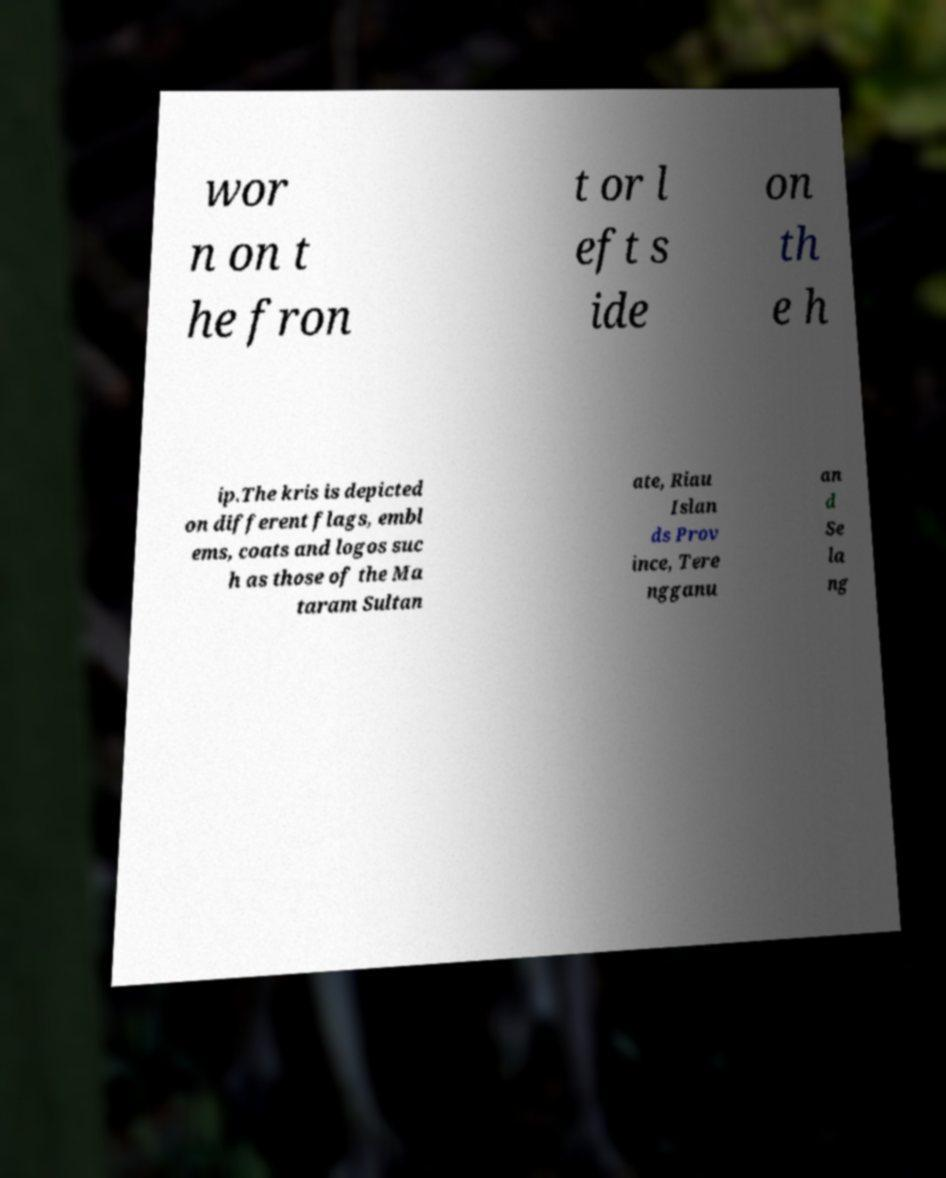Could you extract and type out the text from this image? wor n on t he fron t or l eft s ide on th e h ip.The kris is depicted on different flags, embl ems, coats and logos suc h as those of the Ma taram Sultan ate, Riau Islan ds Prov ince, Tere ngganu an d Se la ng 